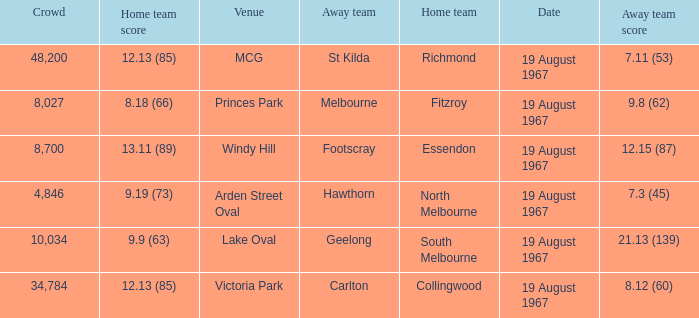If the away team scored 7.3 (45), what was the home team score? 9.19 (73). 